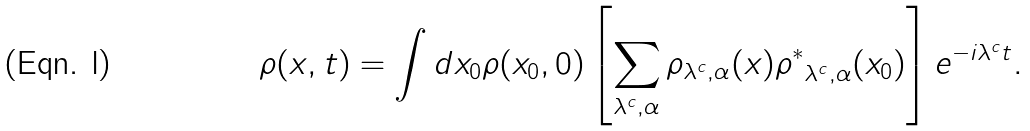Convert formula to latex. <formula><loc_0><loc_0><loc_500><loc_500>\rho ( { x } , t ) = \int d { x } _ { 0 } \rho ( { x } _ { 0 } , 0 ) \left [ \sum _ { \lambda ^ { c } , \alpha } \rho _ { \lambda ^ { c } , \alpha } ( { x } ) { \rho ^ { * } } _ { \lambda ^ { c } , \alpha } ( { x } _ { 0 } ) \right ] e ^ { - i \lambda ^ { c } t } .</formula> 